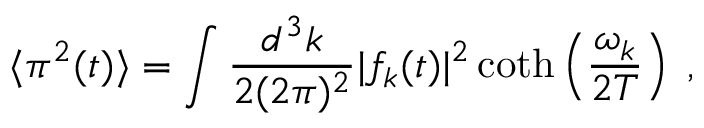Convert formula to latex. <formula><loc_0><loc_0><loc_500><loc_500>\langle \pi ^ { 2 } ( t ) \rangle = \int \frac { d ^ { 3 } k } { 2 ( 2 \pi ) ^ { 2 } } | f _ { k } ( t ) | ^ { 2 } \coth \left ( \frac { \omega _ { k } } { 2 T } \right ) \, ,</formula> 